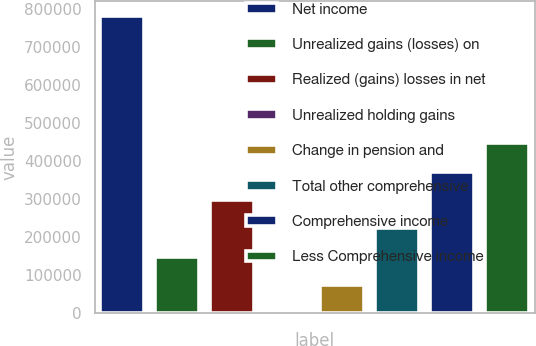Convert chart to OTSL. <chart><loc_0><loc_0><loc_500><loc_500><bar_chart><fcel>Net income<fcel>Unrealized gains (losses) on<fcel>Realized (gains) losses in net<fcel>Unrealized holding gains<fcel>Change in pension and<fcel>Total other comprehensive<fcel>Comprehensive income<fcel>Less Comprehensive income<nl><fcel>780191<fcel>148744<fcel>297440<fcel>47<fcel>74395.3<fcel>223092<fcel>371788<fcel>446137<nl></chart> 